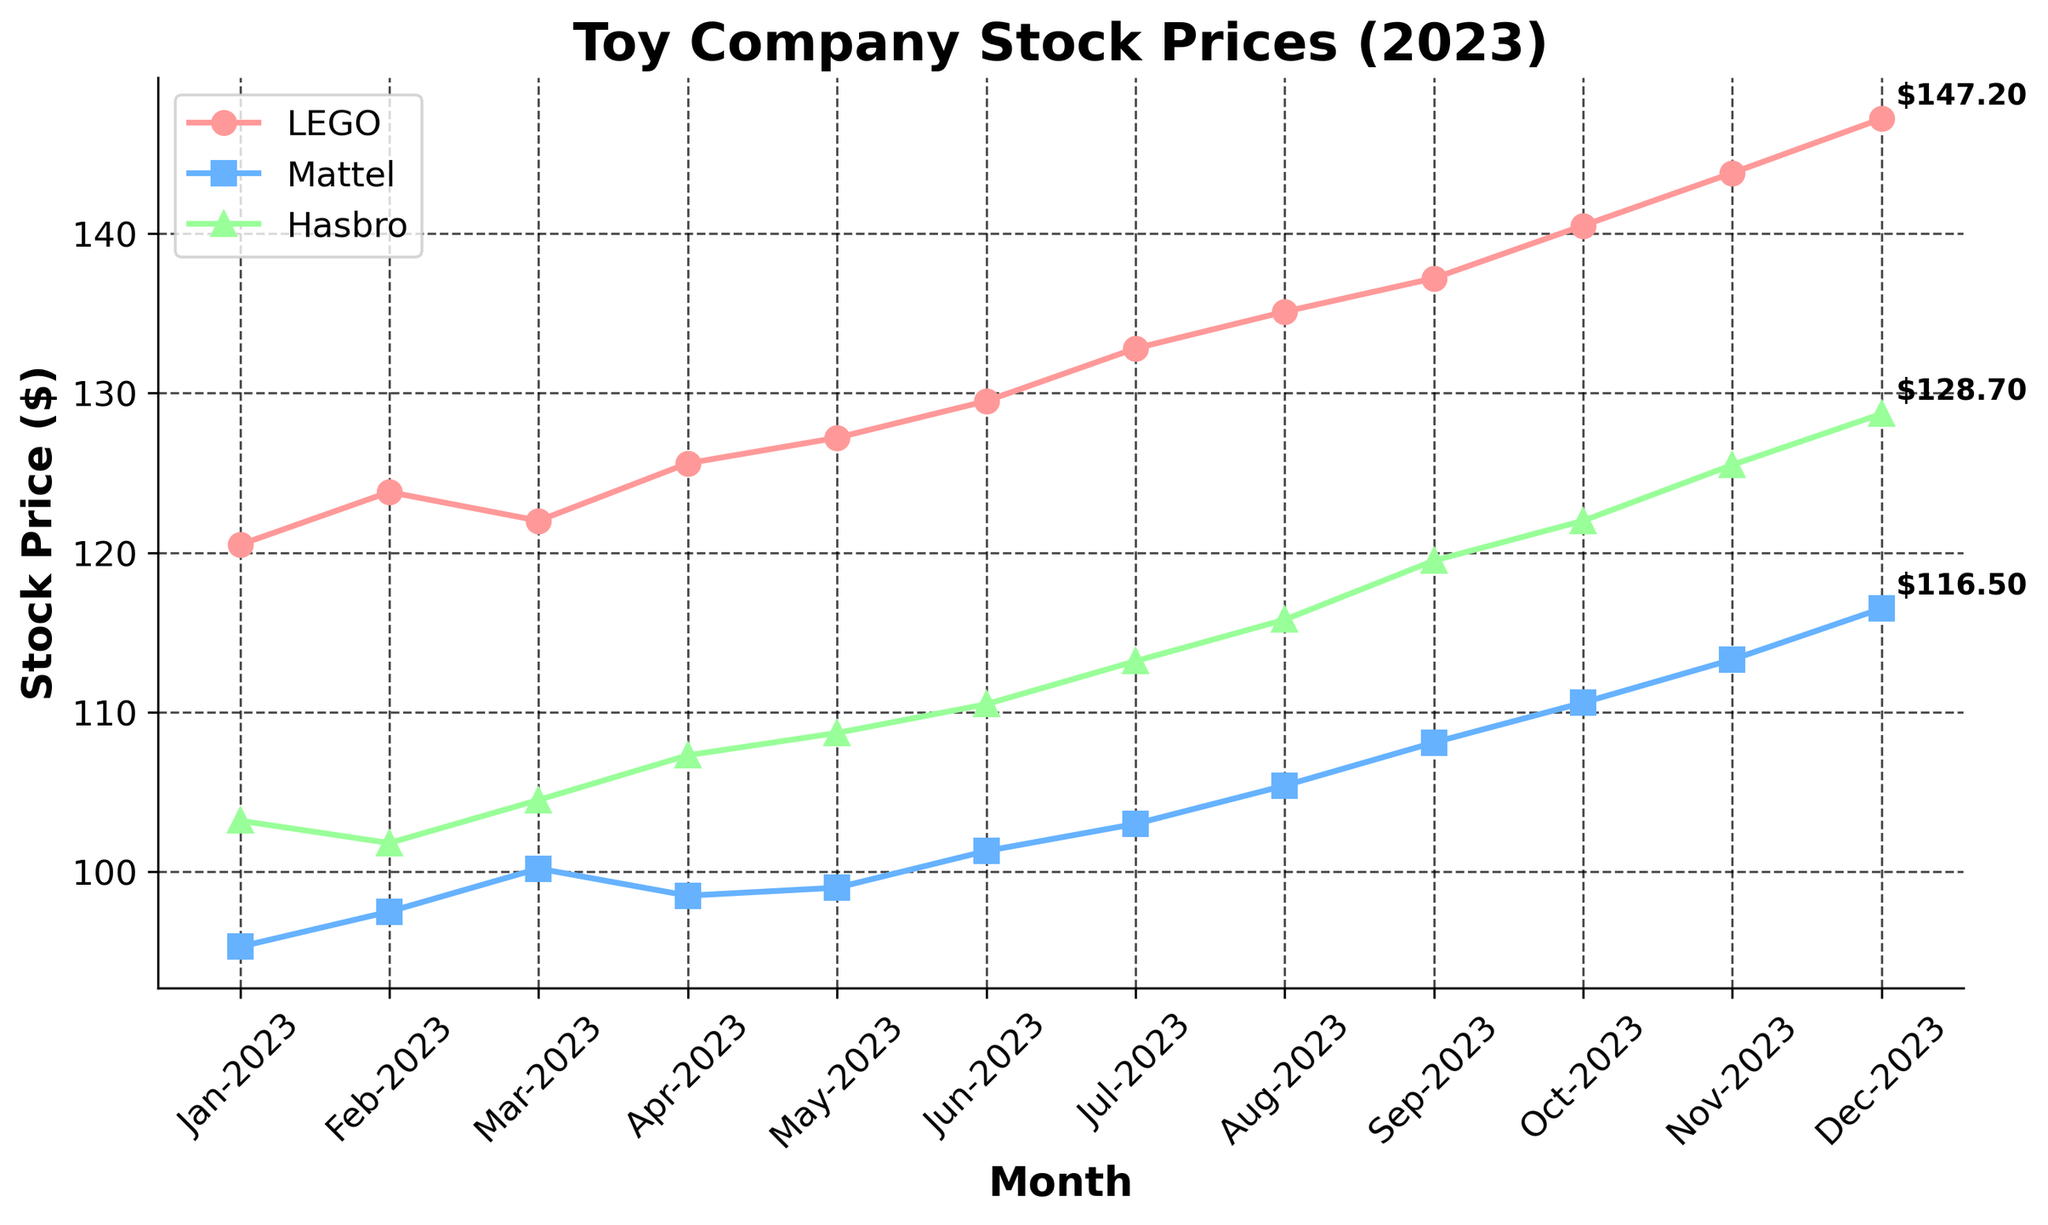What's the title of the figure? The title is clearly displayed at the top of the figure.
Answer: Toy Company Stock Prices (2023) Which company had the highest stock price in December 2023? By referring to the markers and annotations at the end of each line for December 2023, the highest price annotation reads $147.20 for LEGO.
Answer: LEGO Compare the stock prices of Mattel and Hasbro in July 2023. Which one was higher? Locate July 2023 on the x-axis, then refer to the points for Mattel and Hasbro. Mattel's price is $103.00 and Hasbro's is $113.20.
Answer: Hasbro How many companies' stock prices are compared in the plot? By counting the number of distinct lines or the legend entries, three companies (LEGO, Mattel, Hasbro) are represented.
Answer: 3 What was the average stock price of LEGO from January to March 2023? The prices are 120.50, 123.80, and 122.00. Sum these values: 120.50 + 123.80 + 122.00 = 366.30. Then divide by 3 (the number of months): 366.30 / 3 = 122.10.
Answer: 122.10 Which company showed the greatest increase in stock price from January to December 2023? Calculate the stock price difference for each company from January to December (LEGO: 147.20 - 120.50 = 26.70, Mattel: 116.50 - 95.30 = 21.20, Hasbro: 128.70 - 103.20 = 25.50). LEGO's increase of 26.70 is the greatest.
Answer: LEGO What is the lowest stock price recorded for Mattel in 2023 and in which month did it occur? Trace the line for Mattel and find the lowest point, which is $95.30 in January 2023.
Answer: $95.30 in January 2023 Find the month where Hasbro’s stock price was $104.50. Follow the data points for Hasbro to locate the month where the stock price aligns with $104.50, which is in March 2023.
Answer: March 2023 How does the trend of LEGO's stock prices compare to that of Mattel from August to December 2023? By observing both lines from August to December: LEGO consistently increases from 135.10 to 147.20, while Mattel also increases but at a slower rate from 105.40 to 116.50.
Answer: LEGO’s stock increased faster Which company had the most stable stock price over the year 2023 judging by visual inspection? Look at the steepness and fluctuations in each company's line; the less steep and fewer fluctuations suggest stability. Mattel shows the least fluctuation.
Answer: Mattel 